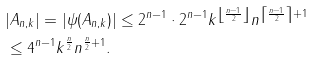Convert formula to latex. <formula><loc_0><loc_0><loc_500><loc_500>& | A _ { n , k } | = | \psi ( A _ { n , k } ) | \leq 2 ^ { n - 1 } \cdot 2 ^ { n - 1 } k ^ { \left \lfloor \frac { n - 1 } { 2 } \right \rfloor } n ^ { \left \lceil \frac { n - 1 } { 2 } \right \rceil + 1 } & \\ & \leq 4 ^ { n - 1 } k ^ { \frac { n } { 2 } } n ^ { \frac { n } { 2 } + 1 } . &</formula> 